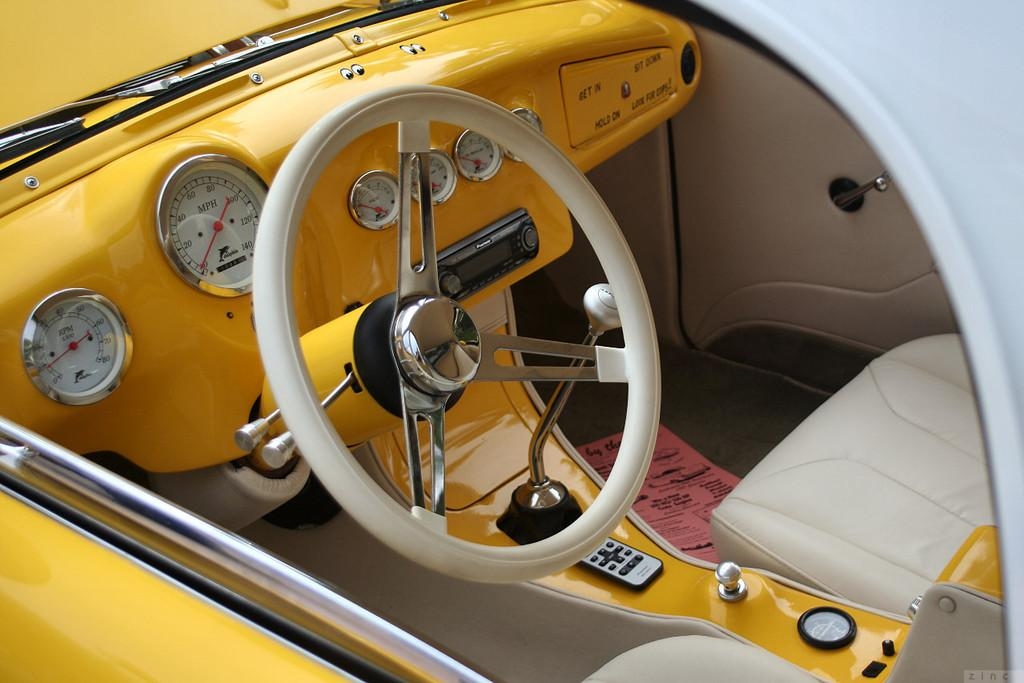What color is the car in the image? The car in the image is yellow. What type of vehicle is the main subject of the image? The main subject of the image is a car. What else can be seen in the image besides the car? There is a paper with text visible in the image. Can you see any bites taken out of the car in the image? No, there are no bites visible on the car in the image. What type of truck is parked next to the car in the image? There is no truck present in the image; it only features a yellow car and a paper with text. 